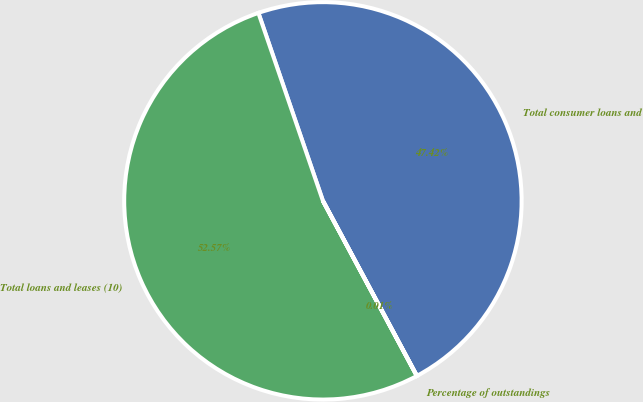Convert chart to OTSL. <chart><loc_0><loc_0><loc_500><loc_500><pie_chart><fcel>Total consumer loans and<fcel>Total loans and leases (10)<fcel>Percentage of outstandings<nl><fcel>47.42%<fcel>52.57%<fcel>0.01%<nl></chart> 